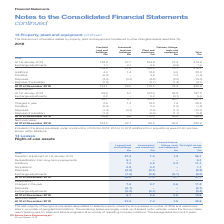According to Spirax Sarco Engineering Plc's financial document, What is the vast majority of the right-of-use asset value related to? leased property where the Group leases a number of office and warehouse sites in a number of geographical locations. The document states: "jority of the right-of-use asset value relates to leased property where the Group leases a number of office and warehouse sites in a number of geograp..." Also, What is the average lease term? According to the financial document, 4.3 years. The relevant text states: "ting company locations. The average lease term is 4.3 years...." Also, What are the different types of leases making up the right-of-use assets in the table? The document contains multiple relevant values: Leased land and buildings, Leased plants and machinery, Leased fixtures, fittings, tools and equipment. From the document: "Leased land and buildings £m Leased fixtures, fittings, tools and equipment £m..." Additionally, Which type of lease had the largest amount of Acquisitions? Leased land and buildings. The document states: "Leased land and buildings £m..." Also, can you calculate: What was the total net book value of leased land and buildings and leased plant and machinery? Based on the calculation: 31.9+7.4, the result is 39.3 (in millions). This is based on the information: "Net book value: At 31st December 2019 31.9 7.4 1.5 40.8 Net book value: At 31st December 2019 31.9 7.4 1.5 40.8..." The key data points involved are: 31.9, 7.4. Also, can you calculate: What was the sum of net book values of leased land and buildings and leased plant and machinery as a percentage of the net book value of the total right-of-use assets? To answer this question, I need to perform calculations using the financial data. The calculation is: (31.9+7.4)/40.8, which equals 96.32 (percentage). This is based on the information: "Net book value: At 31st December 2019 31.9 7.4 1.5 40.8 Net book value: At 31st December 2019 31.9 7.4 1.5 40.8 et book value: At 31st December 2019 31.9 7.4 1.5 40.8..." The key data points involved are: 31.9, 40.8, 7.4. 